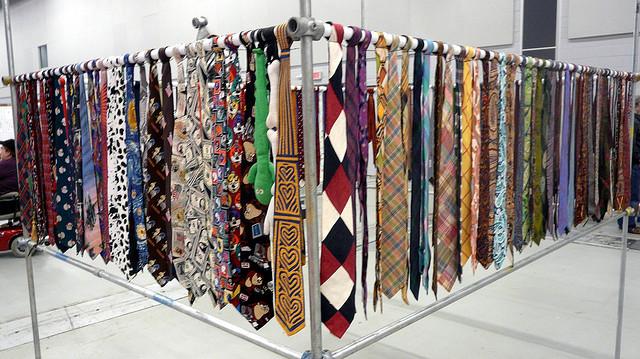What mans accessory is being displayed?
Be succinct. Tie. Is there a heart-patterned tie?
Concise answer only. No. Do any of the ties look alike?
Concise answer only. No. 